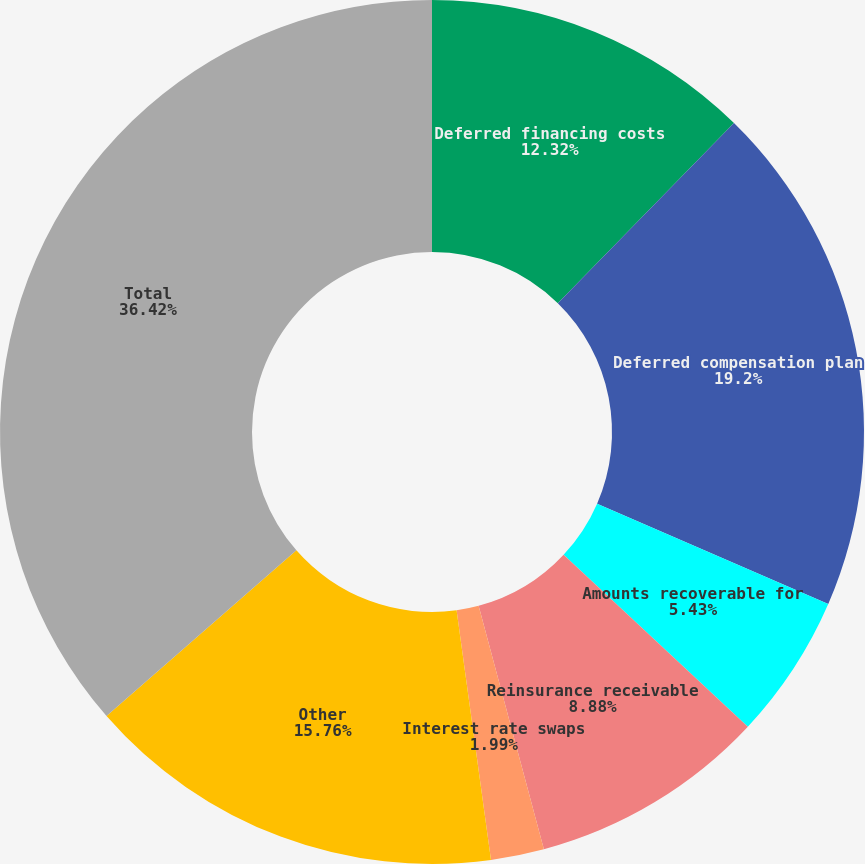<chart> <loc_0><loc_0><loc_500><loc_500><pie_chart><fcel>Deferred financing costs<fcel>Deferred compensation plan<fcel>Amounts recoverable for<fcel>Reinsurance receivable<fcel>Interest rate swaps<fcel>Other<fcel>Total<nl><fcel>12.32%<fcel>19.2%<fcel>5.43%<fcel>8.88%<fcel>1.99%<fcel>15.76%<fcel>36.42%<nl></chart> 